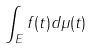Convert formula to latex. <formula><loc_0><loc_0><loc_500><loc_500>\int _ { E } f ( t ) d \mu ( t )</formula> 